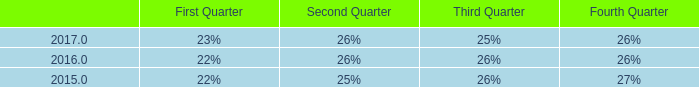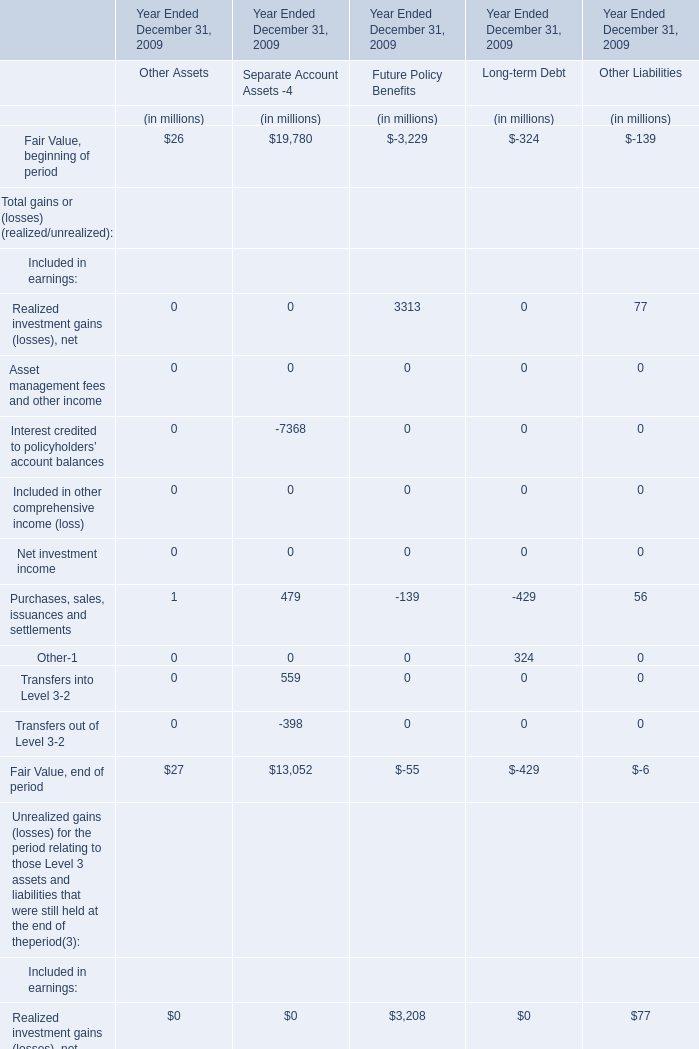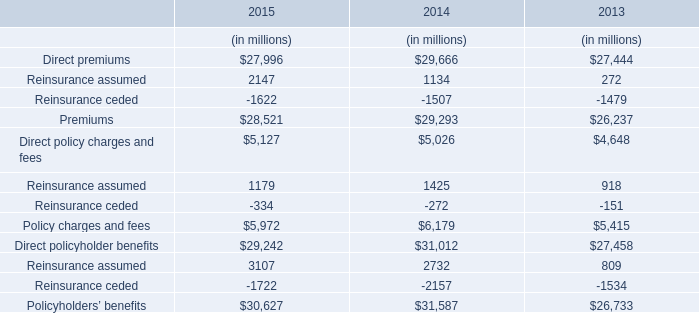considering the years 2016-2017 , what is the increase observed in the research and development expenditures? 
Computations: ((48.3 / 47.3) - 1)
Answer: 0.02114. 